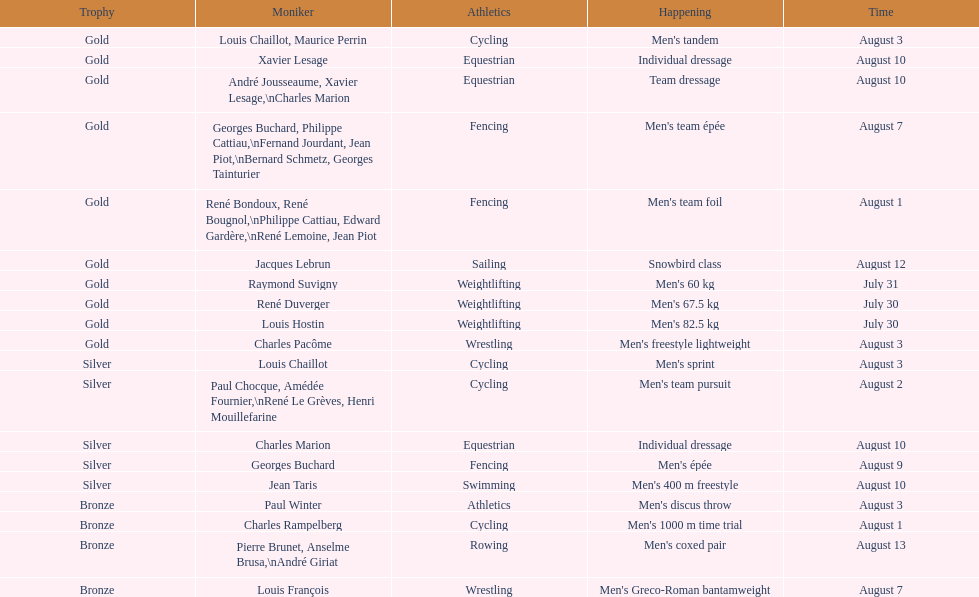Which event won the most medals? Cycling. 